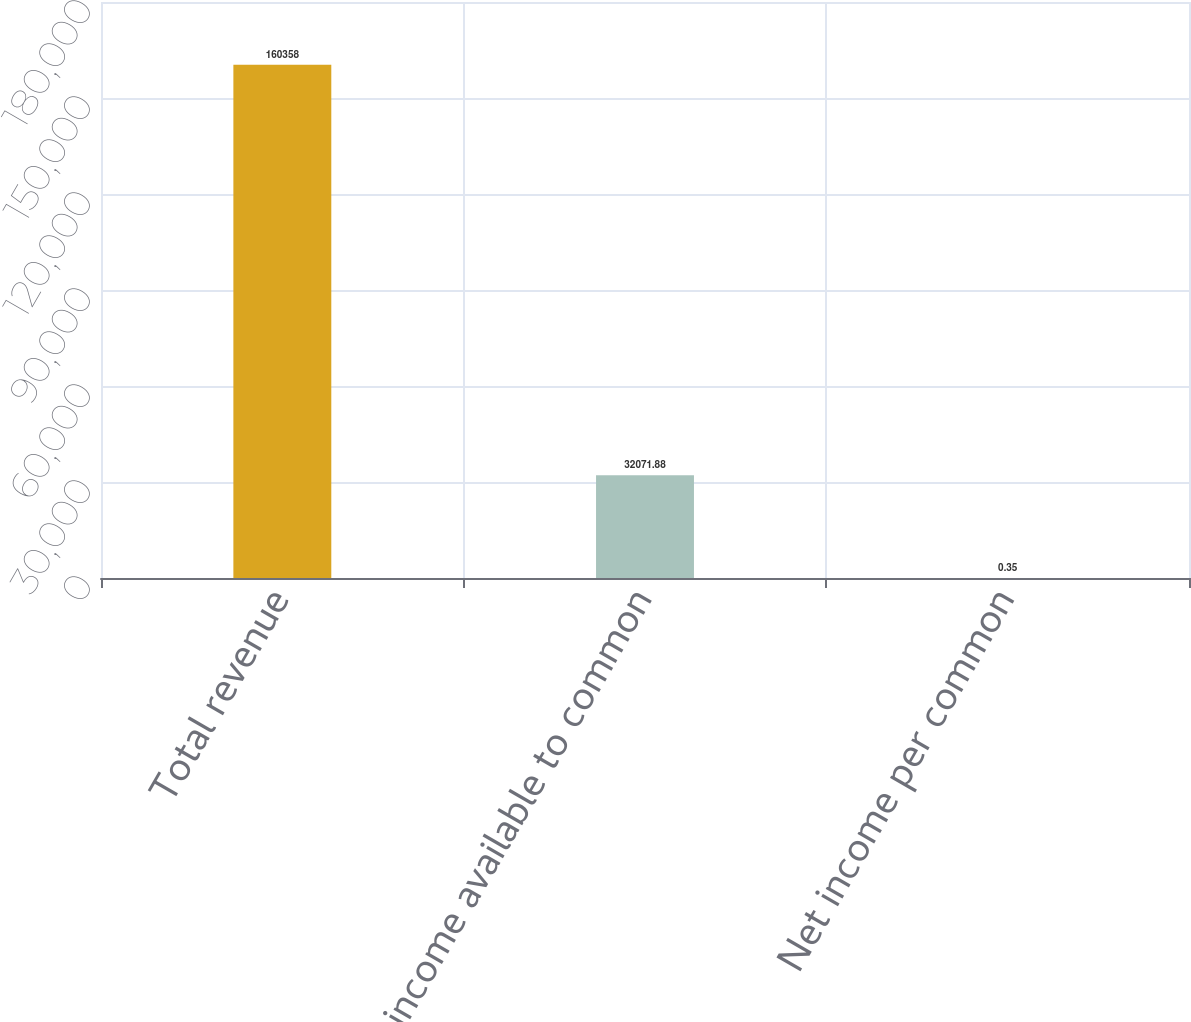Convert chart to OTSL. <chart><loc_0><loc_0><loc_500><loc_500><bar_chart><fcel>Total revenue<fcel>Net income available to common<fcel>Net income per common<nl><fcel>160358<fcel>32071.9<fcel>0.35<nl></chart> 